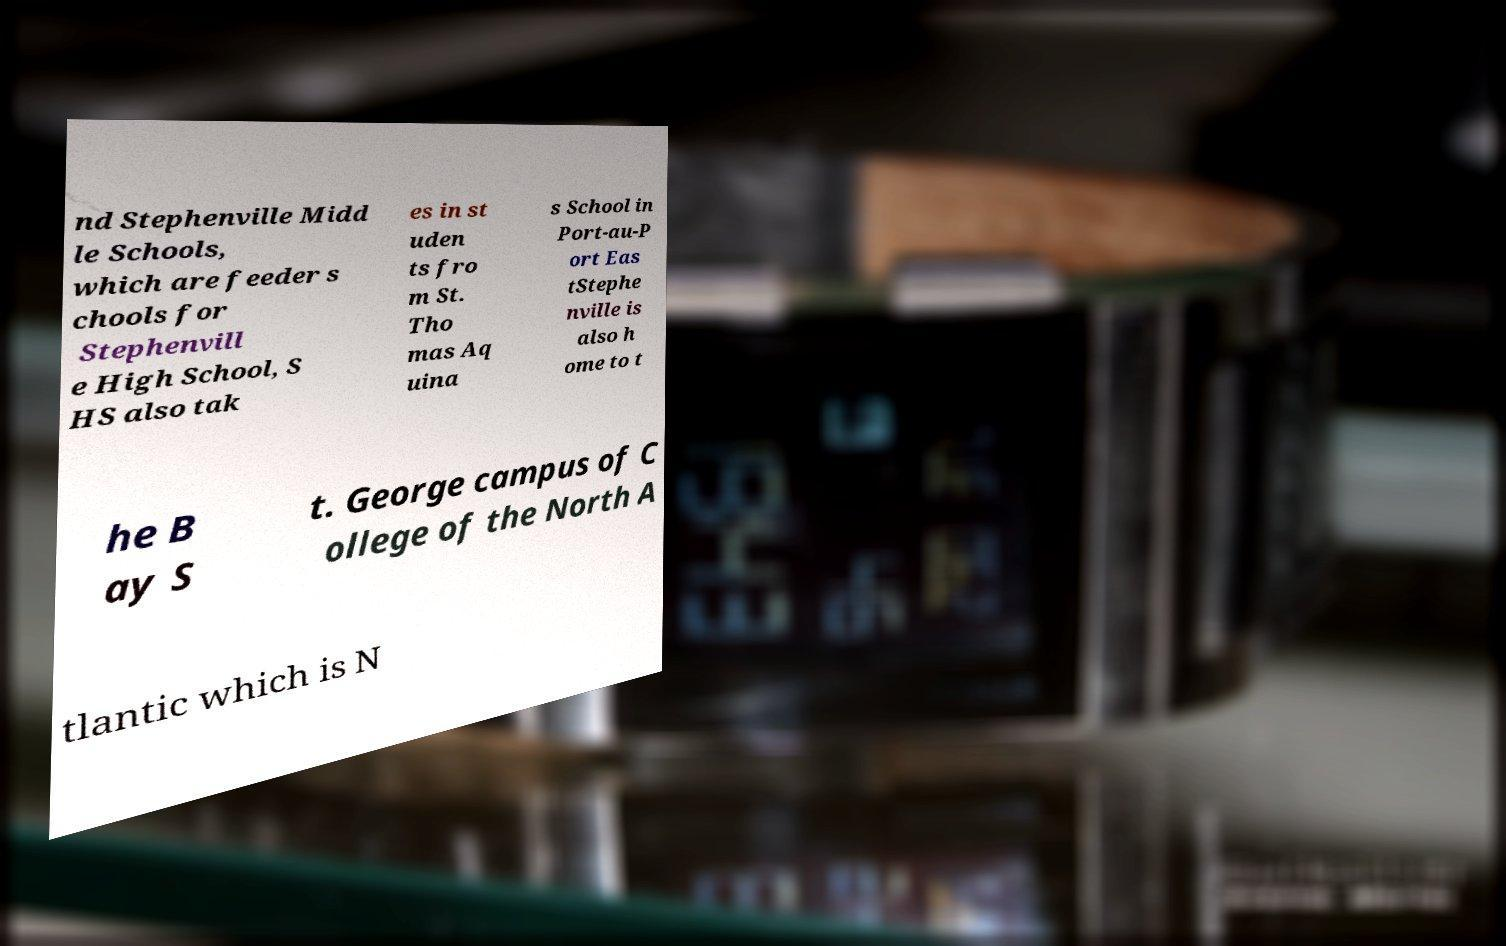Can you read and provide the text displayed in the image?This photo seems to have some interesting text. Can you extract and type it out for me? nd Stephenville Midd le Schools, which are feeder s chools for Stephenvill e High School, S HS also tak es in st uden ts fro m St. Tho mas Aq uina s School in Port-au-P ort Eas tStephe nville is also h ome to t he B ay S t. George campus of C ollege of the North A tlantic which is N 